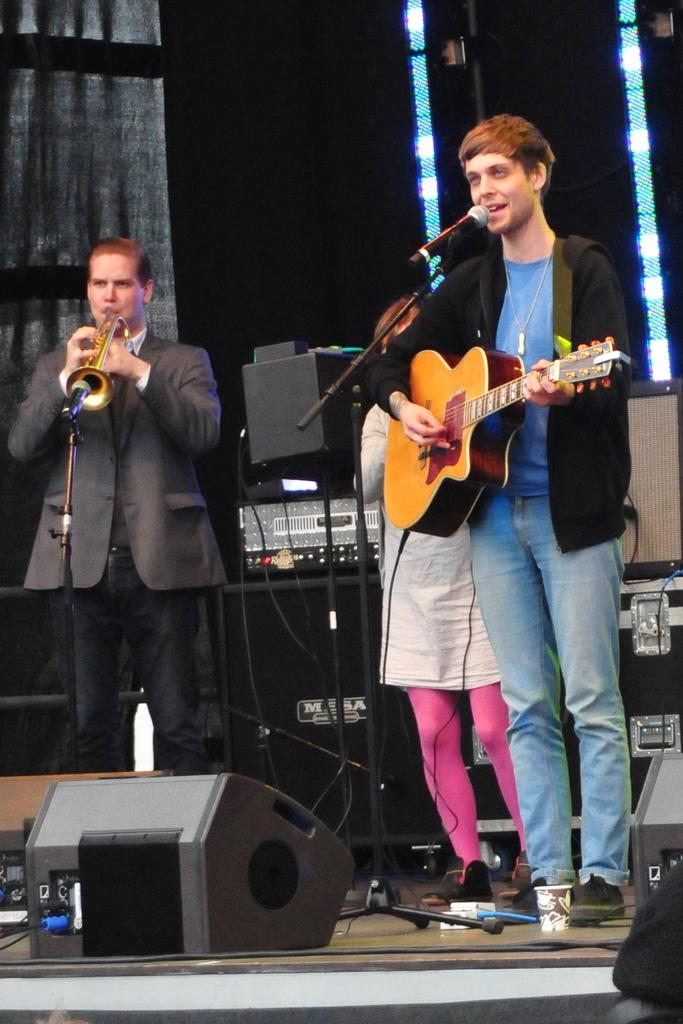How many people are in the image? There are three persons in the image. What is one of the men holding? One man is holding a guitar. What is the other man doing with a musical instrument? The other man is playing a musical instrument. Where are they performing? They are on a stage. What type of transport can be seen on the stage in the image? There is no transport visible on the stage in the image. What ornament is hanging from the ceiling above the stage? There is no ornament mentioned or visible in the image. 